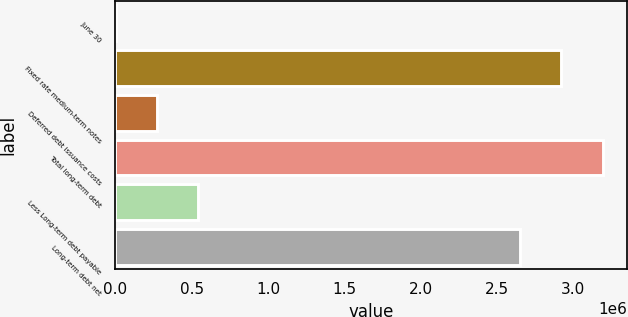Convert chart to OTSL. <chart><loc_0><loc_0><loc_500><loc_500><bar_chart><fcel>June 30<fcel>Fixed rate medium-term notes<fcel>Deferred debt issuance costs<fcel>Total long-term debt<fcel>Less Long-term debt payable<fcel>Long-term debt net<nl><fcel>2016<fcel>2.92331e+06<fcel>272869<fcel>3.19416e+06<fcel>543722<fcel>2.65246e+06<nl></chart> 